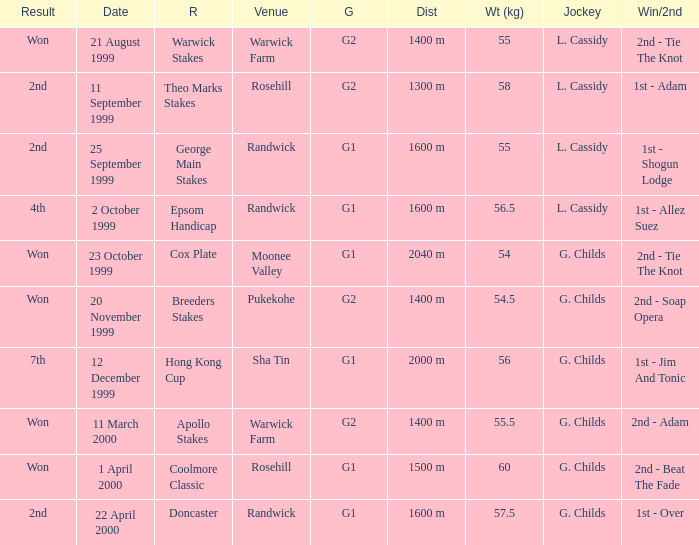List the weight for 56 kilograms. 2000 m. I'm looking to parse the entire table for insights. Could you assist me with that? {'header': ['Result', 'Date', 'R', 'Venue', 'G', 'Dist', 'Wt (kg)', 'Jockey', 'Win/2nd'], 'rows': [['Won', '21 August 1999', 'Warwick Stakes', 'Warwick Farm', 'G2', '1400 m', '55', 'L. Cassidy', '2nd - Tie The Knot'], ['2nd', '11 September 1999', 'Theo Marks Stakes', 'Rosehill', 'G2', '1300 m', '58', 'L. Cassidy', '1st - Adam'], ['2nd', '25 September 1999', 'George Main Stakes', 'Randwick', 'G1', '1600 m', '55', 'L. Cassidy', '1st - Shogun Lodge'], ['4th', '2 October 1999', 'Epsom Handicap', 'Randwick', 'G1', '1600 m', '56.5', 'L. Cassidy', '1st - Allez Suez'], ['Won', '23 October 1999', 'Cox Plate', 'Moonee Valley', 'G1', '2040 m', '54', 'G. Childs', '2nd - Tie The Knot'], ['Won', '20 November 1999', 'Breeders Stakes', 'Pukekohe', 'G2', '1400 m', '54.5', 'G. Childs', '2nd - Soap Opera'], ['7th', '12 December 1999', 'Hong Kong Cup', 'Sha Tin', 'G1', '2000 m', '56', 'G. Childs', '1st - Jim And Tonic'], ['Won', '11 March 2000', 'Apollo Stakes', 'Warwick Farm', 'G2', '1400 m', '55.5', 'G. Childs', '2nd - Adam'], ['Won', '1 April 2000', 'Coolmore Classic', 'Rosehill', 'G1', '1500 m', '60', 'G. Childs', '2nd - Beat The Fade'], ['2nd', '22 April 2000', 'Doncaster', 'Randwick', 'G1', '1600 m', '57.5', 'G. Childs', '1st - Over']]} 